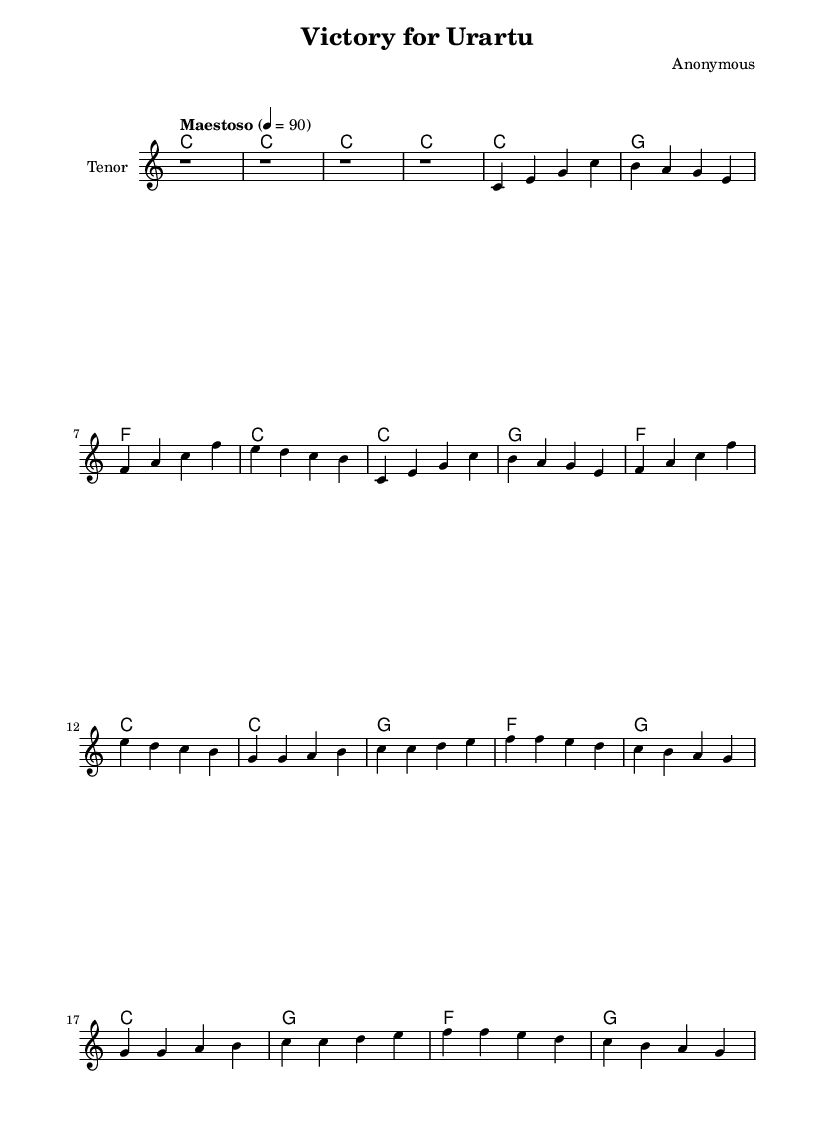What is the key signature of this music? The key signature is C major, which has no sharps or flats indicated on the staff. The absence of flats or sharps confirms this.
Answer: C major What is the time signature of this piece? The time signature shown at the beginning of the music is 4/4, which indicates four beats per measure. This is identifiable from the notation at the start of the first measure.
Answer: 4/4 What is the tempo marking for this music? The tempo marking specified is "Maestoso" with a metronomic marking of 4 = 90, indicating a slow and majestic pace. This is found beneath the header section at the start of the score.
Answer: Maestoso How many measures are in the chorus? There are a total of 8 measures in the chorus section, which can be counted by examining the repeat of the melody and its alignment with the lyrics provided.
Answer: 8 What is the primary theme of the lyrics? The primary theme of the lyrics is celebrating the football club Urartu's pride and victories, emphasized through repetition and joyful expression in the words. This is observed in both the verse and chorus sections.
Answer: Celebration Which voice type is suitable for this piece? The score indicates a tenor voice, which is typical for heroic arias in opera, suggesting that the music is meant for a tenor to sing. This is specified on the score next to the staff name.
Answer: Tenor What is the harmonic progression used in the verse? The harmonic progression used in the verse follows a pattern of C, G, F, and C, which creates a simple yet effective structure for the melody. This is derived by analyzing the chord symbols corresponding to the melody in the verse section.
Answer: C, G, F, C 